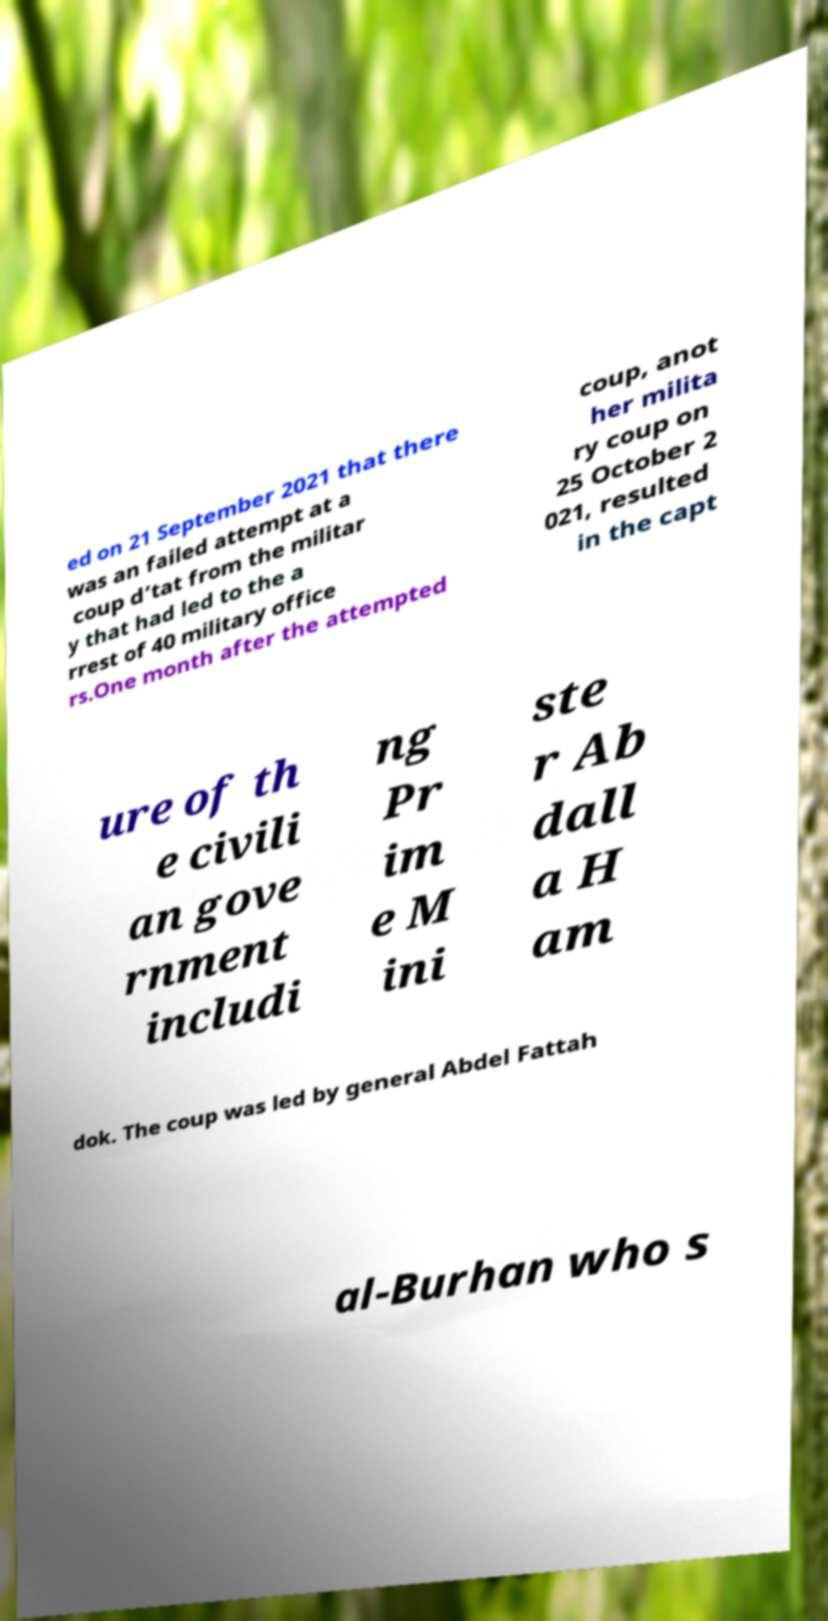There's text embedded in this image that I need extracted. Can you transcribe it verbatim? ed on 21 September 2021 that there was an failed attempt at a coup d’tat from the militar y that had led to the a rrest of 40 military office rs.One month after the attempted coup, anot her milita ry coup on 25 October 2 021, resulted in the capt ure of th e civili an gove rnment includi ng Pr im e M ini ste r Ab dall a H am dok. The coup was led by general Abdel Fattah al-Burhan who s 